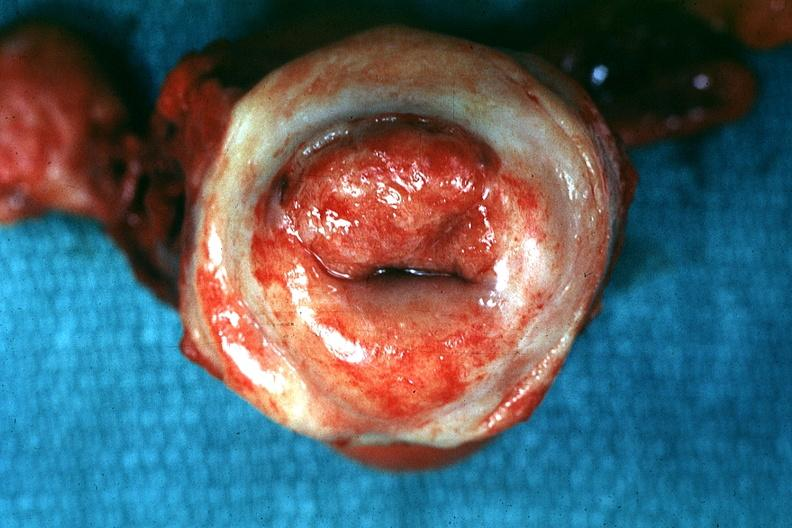s cervical carcinoma present?
Answer the question using a single word or phrase. Yes 